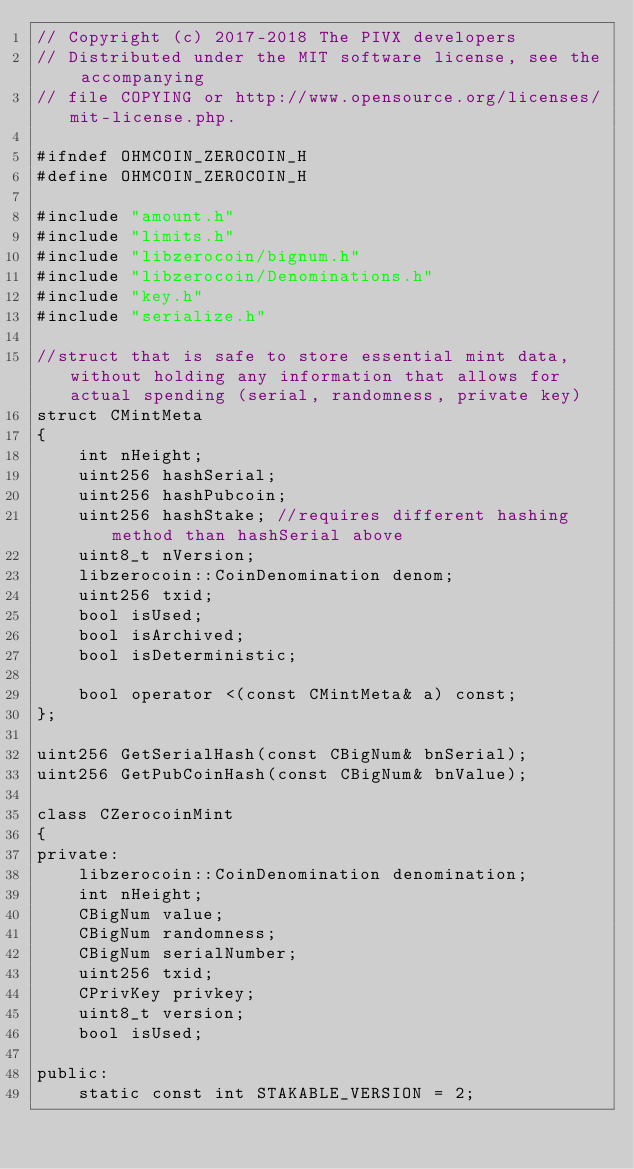Convert code to text. <code><loc_0><loc_0><loc_500><loc_500><_C_>// Copyright (c) 2017-2018 The PIVX developers
// Distributed under the MIT software license, see the accompanying
// file COPYING or http://www.opensource.org/licenses/mit-license.php.

#ifndef OHMCOIN_ZEROCOIN_H
#define OHMCOIN_ZEROCOIN_H

#include "amount.h"
#include "limits.h"
#include "libzerocoin/bignum.h"
#include "libzerocoin/Denominations.h"
#include "key.h"
#include "serialize.h"

//struct that is safe to store essential mint data, without holding any information that allows for actual spending (serial, randomness, private key)
struct CMintMeta
{
    int nHeight;
    uint256 hashSerial;
    uint256 hashPubcoin;
    uint256 hashStake; //requires different hashing method than hashSerial above
    uint8_t nVersion;
    libzerocoin::CoinDenomination denom;
    uint256 txid;
    bool isUsed;
    bool isArchived;
    bool isDeterministic;

    bool operator <(const CMintMeta& a) const;
};

uint256 GetSerialHash(const CBigNum& bnSerial);
uint256 GetPubCoinHash(const CBigNum& bnValue);

class CZerocoinMint
{
private:
    libzerocoin::CoinDenomination denomination;
    int nHeight;
    CBigNum value;
    CBigNum randomness;
    CBigNum serialNumber;
    uint256 txid;
    CPrivKey privkey;
    uint8_t version;
    bool isUsed;

public:
    static const int STAKABLE_VERSION = 2;</code> 